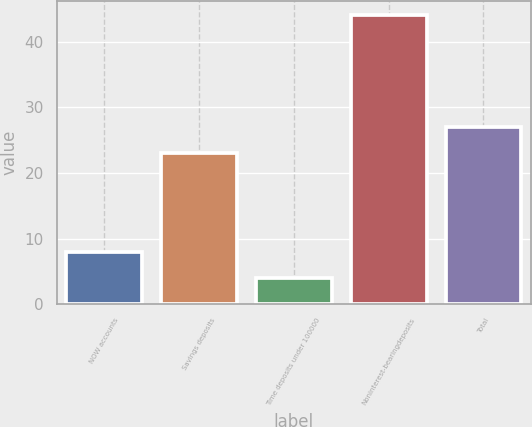Convert chart. <chart><loc_0><loc_0><loc_500><loc_500><bar_chart><fcel>NOW accounts<fcel>Savings deposits<fcel>Time deposits under 100000<fcel>Noninterest-bearingdeposits<fcel>Total<nl><fcel>8<fcel>23<fcel>4<fcel>44<fcel>27<nl></chart> 